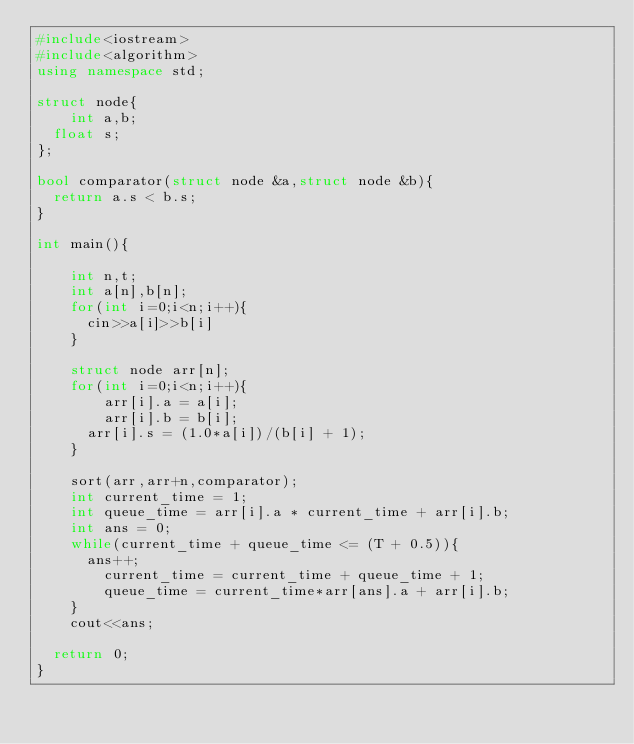<code> <loc_0><loc_0><loc_500><loc_500><_C++_>#include<iostream>
#include<algorithm>
using namespace std;

struct node{
  	int a,b;
	float s;
};

bool comparator(struct node &a,struct node &b){
	return a.s < b.s;
}

int main(){
  
  	int n,t;
  	int a[n],b[n];
  	for(int i=0;i<n;i++){
    	cin>>a[i]>>b[i]
    }
  
  	struct node arr[n];
  	for(int i=0;i<n;i++){
      	arr[i].a = a[i];
      	arr[i].b = b[i];
    	arr[i].s = (1.0*a[i])/(b[i] + 1);
    }
  
  	sort(arr,arr+n,comparator);
  	int current_time = 1;
  	int queue_time = arr[i].a * current_time + arr[i].b;
  	int ans = 0;
  	while(current_time + queue_time <= (T + 0.5)){
    	ans++;
      	current_time = current_time + queue_time + 1;
      	queue_time = current_time*arr[ans].a + arr[i].b;
    }
  	cout<<ans;

	return 0;
}</code> 